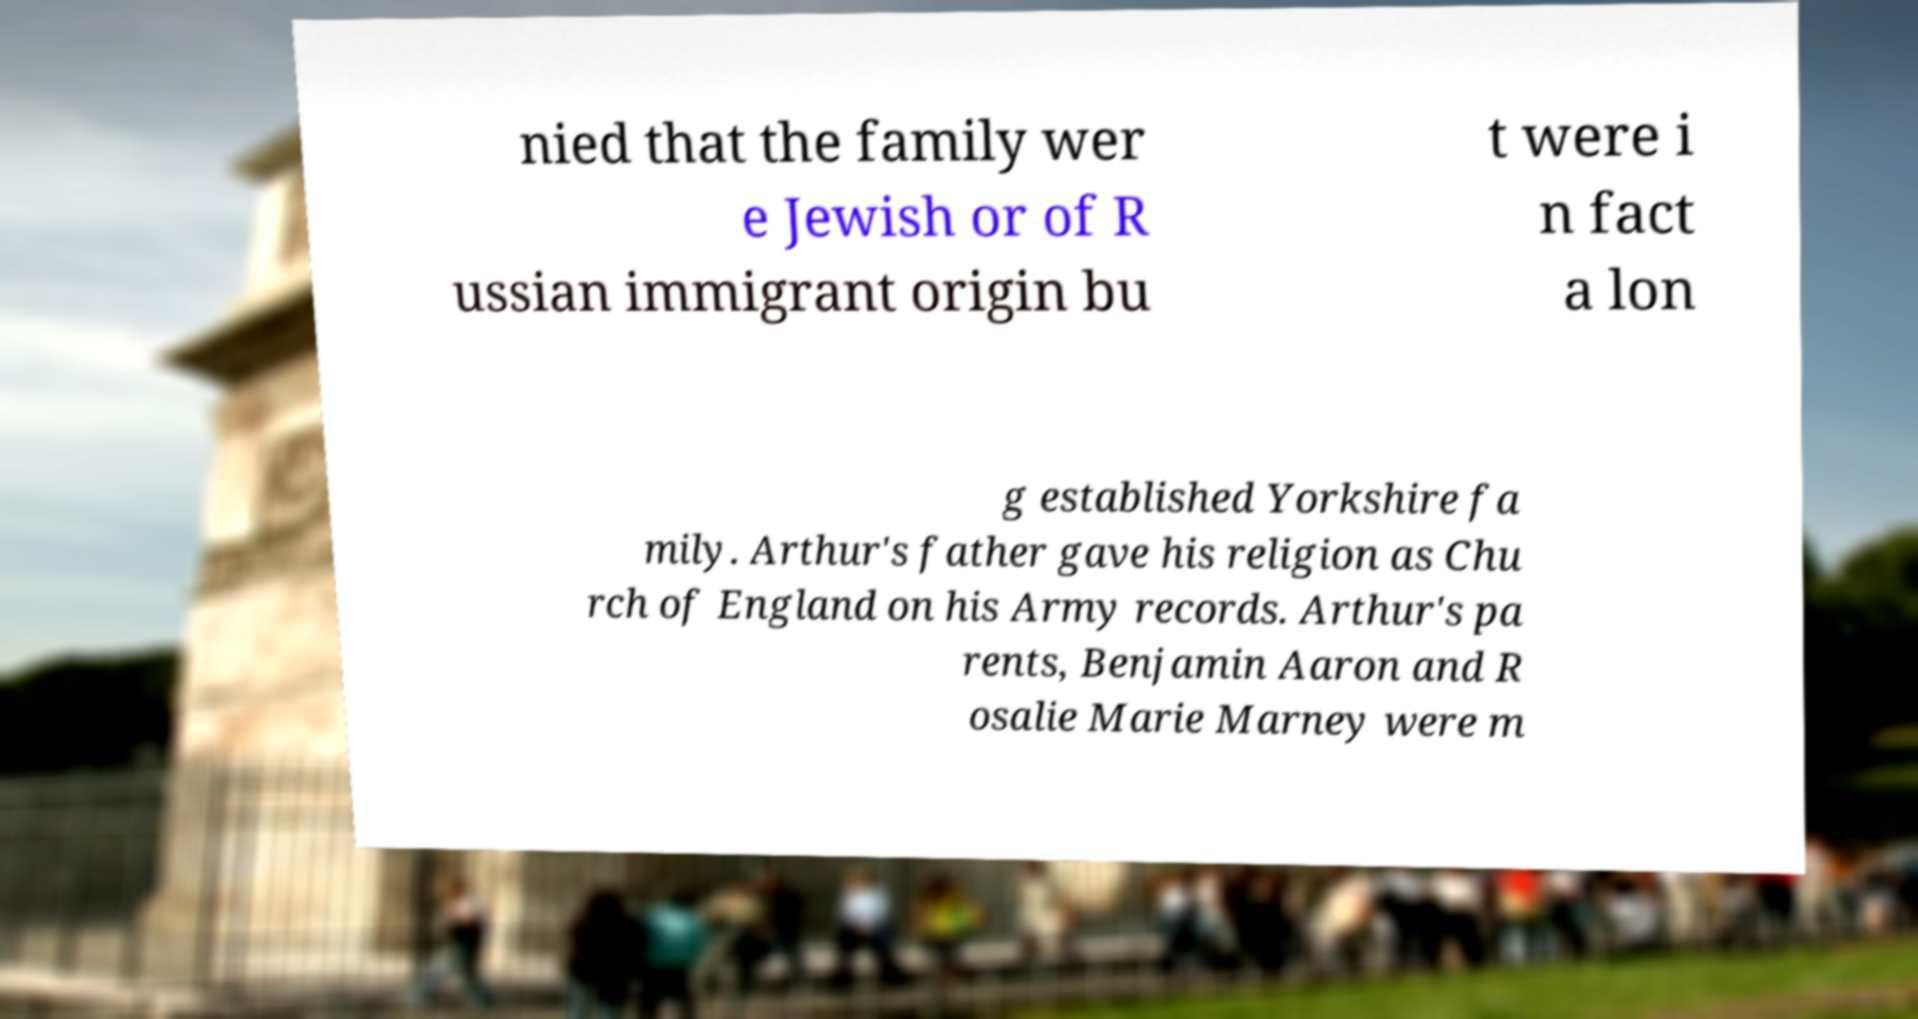Could you extract and type out the text from this image? nied that the family wer e Jewish or of R ussian immigrant origin bu t were i n fact a lon g established Yorkshire fa mily. Arthur's father gave his religion as Chu rch of England on his Army records. Arthur's pa rents, Benjamin Aaron and R osalie Marie Marney were m 